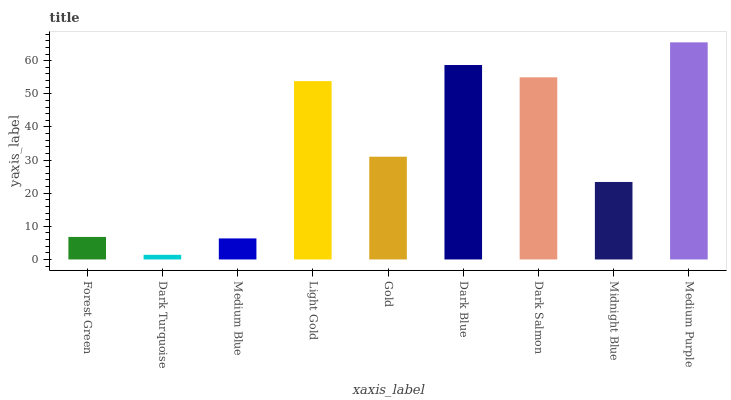Is Dark Turquoise the minimum?
Answer yes or no. Yes. Is Medium Purple the maximum?
Answer yes or no. Yes. Is Medium Blue the minimum?
Answer yes or no. No. Is Medium Blue the maximum?
Answer yes or no. No. Is Medium Blue greater than Dark Turquoise?
Answer yes or no. Yes. Is Dark Turquoise less than Medium Blue?
Answer yes or no. Yes. Is Dark Turquoise greater than Medium Blue?
Answer yes or no. No. Is Medium Blue less than Dark Turquoise?
Answer yes or no. No. Is Gold the high median?
Answer yes or no. Yes. Is Gold the low median?
Answer yes or no. Yes. Is Midnight Blue the high median?
Answer yes or no. No. Is Dark Salmon the low median?
Answer yes or no. No. 